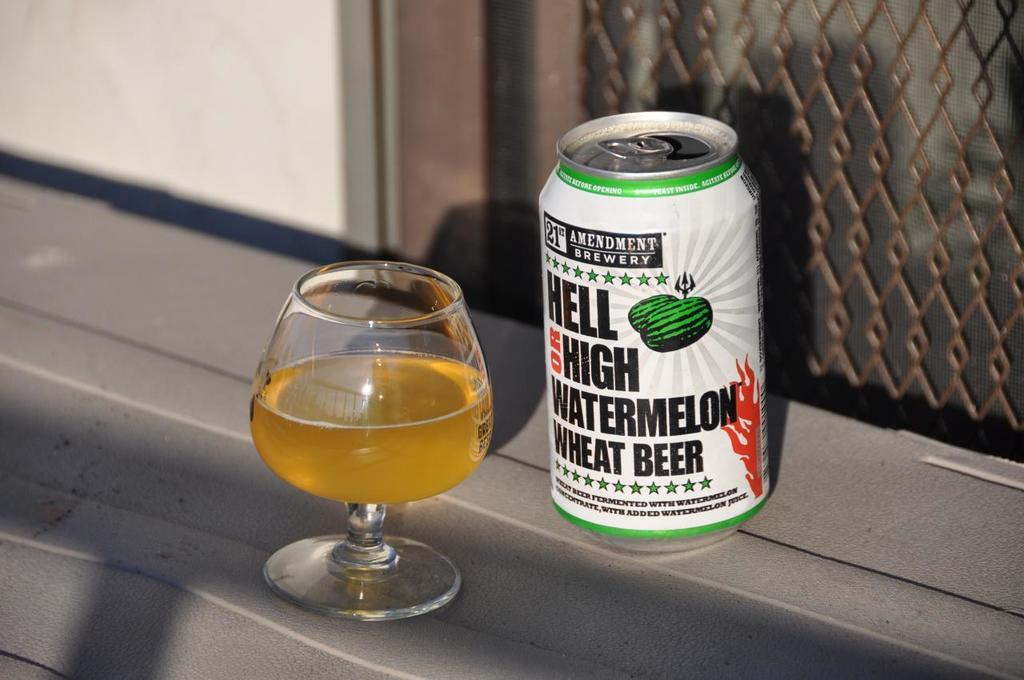Provide a one-sentence caption for the provided image. Hell on high watermelon wheat beer can with a glass of beer. 